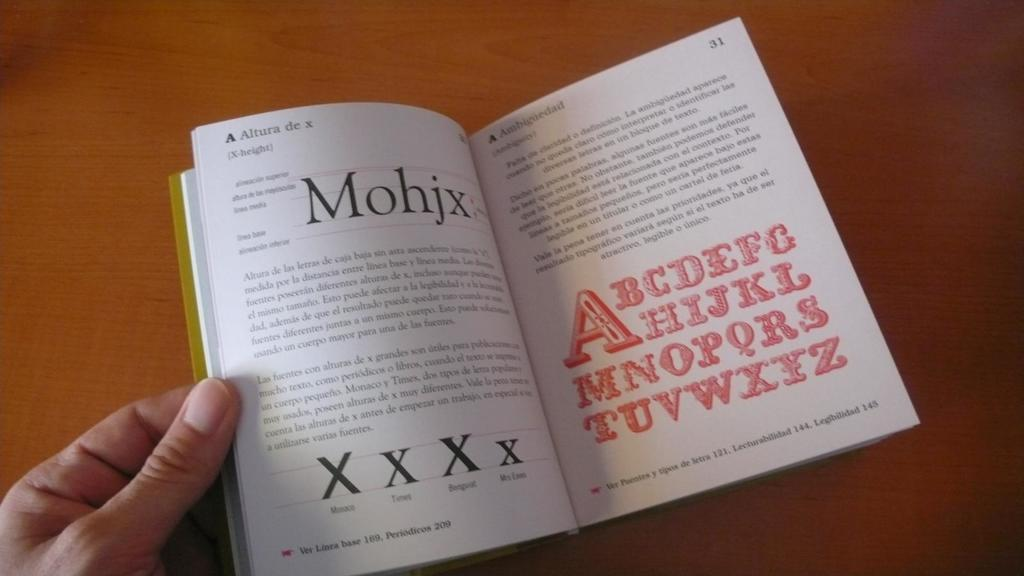<image>
Offer a succinct explanation of the picture presented. A book is opened to a page on the left that says Altura de x. 